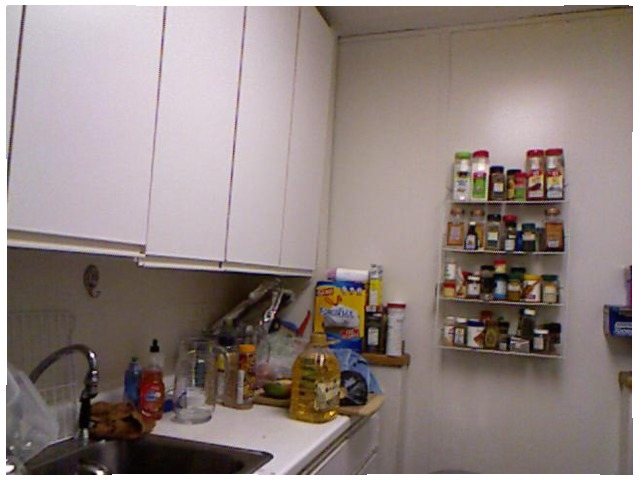<image>
Is the spice on the spice rack? Yes. Looking at the image, I can see the spice is positioned on top of the spice rack, with the spice rack providing support. 